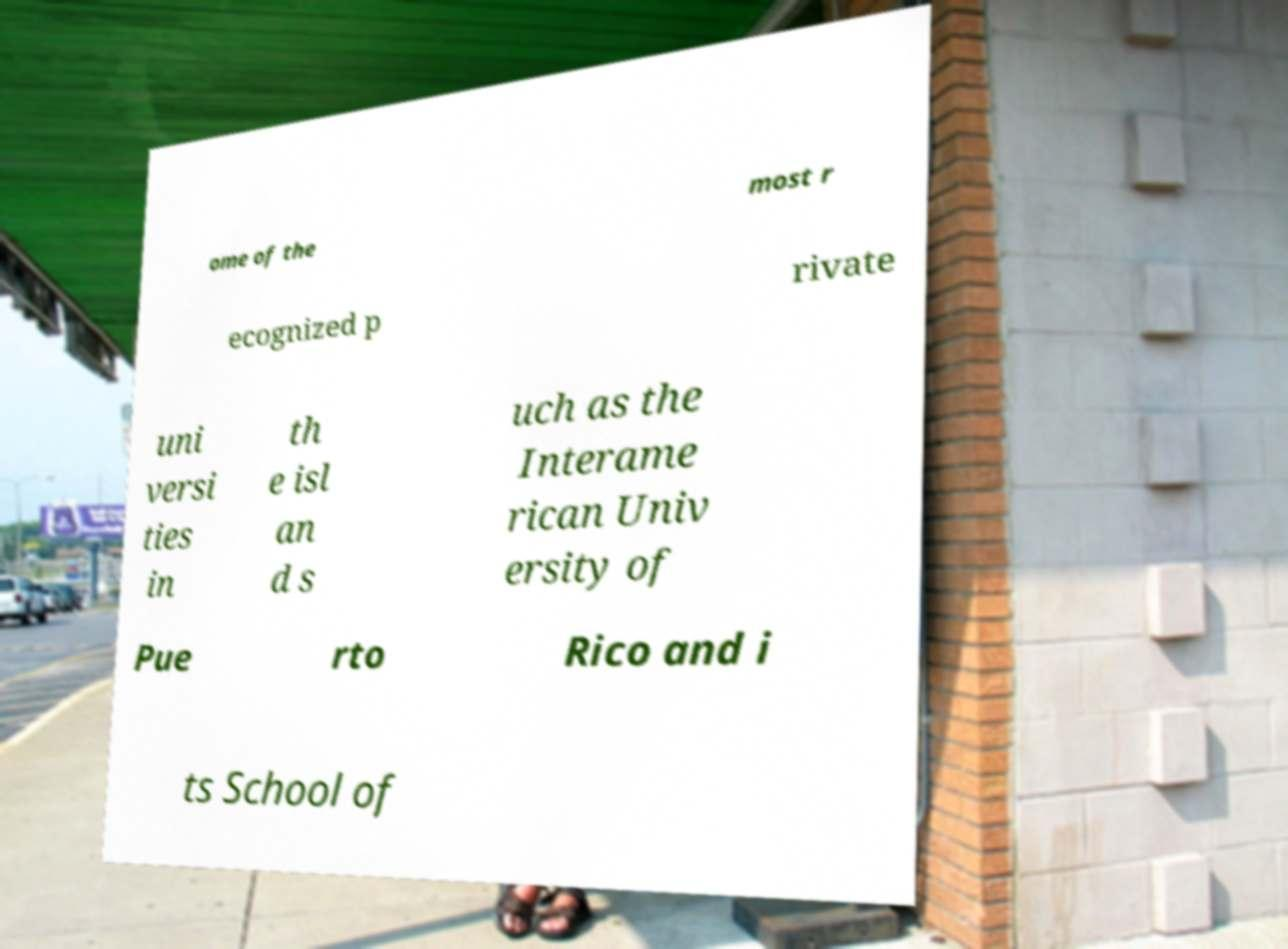For documentation purposes, I need the text within this image transcribed. Could you provide that? ome of the most r ecognized p rivate uni versi ties in th e isl an d s uch as the Interame rican Univ ersity of Pue rto Rico and i ts School of 